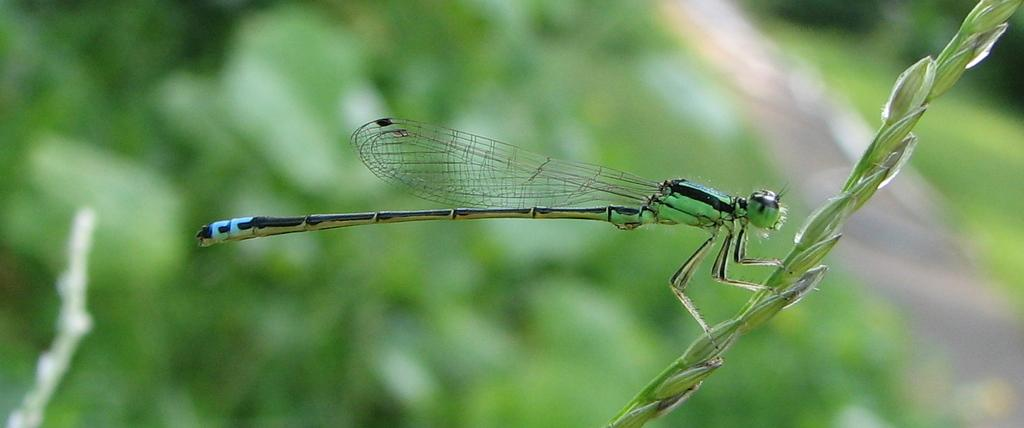What is the main subject of the image? There is a dragonfly in the image. Where is the dragonfly located? The dragonfly is on a stem. Can you describe the background of the image? The background of the image is blurred. What color are the dad's feet on the sofa in the image? There is no dad, feet, or sofa present in the image; it features a dragonfly on a stem with a blurred background. 